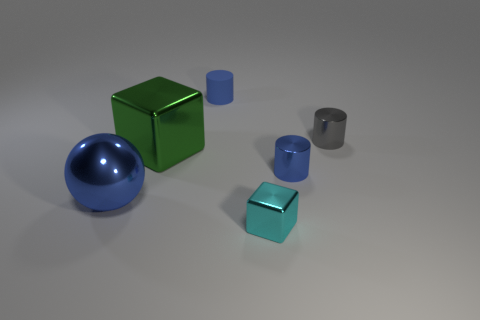Add 1 tiny blue matte cylinders. How many objects exist? 7 Subtract all blocks. How many objects are left? 4 Subtract 1 blue spheres. How many objects are left? 5 Subtract all cyan rubber things. Subtract all cylinders. How many objects are left? 3 Add 3 cyan objects. How many cyan objects are left? 4 Add 4 shiny cylinders. How many shiny cylinders exist? 6 